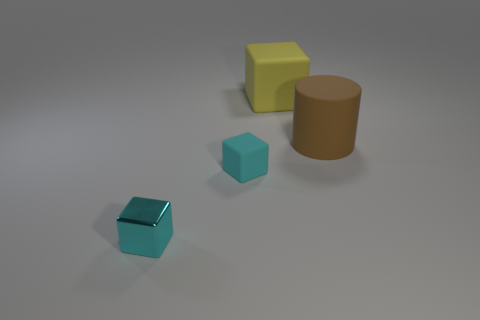Add 1 yellow matte things. How many objects exist? 5 Subtract all cubes. How many objects are left? 1 Subtract 0 red balls. How many objects are left? 4 Subtract all yellow objects. Subtract all matte cylinders. How many objects are left? 2 Add 1 matte objects. How many matte objects are left? 4 Add 1 big gray rubber spheres. How many big gray rubber spheres exist? 1 